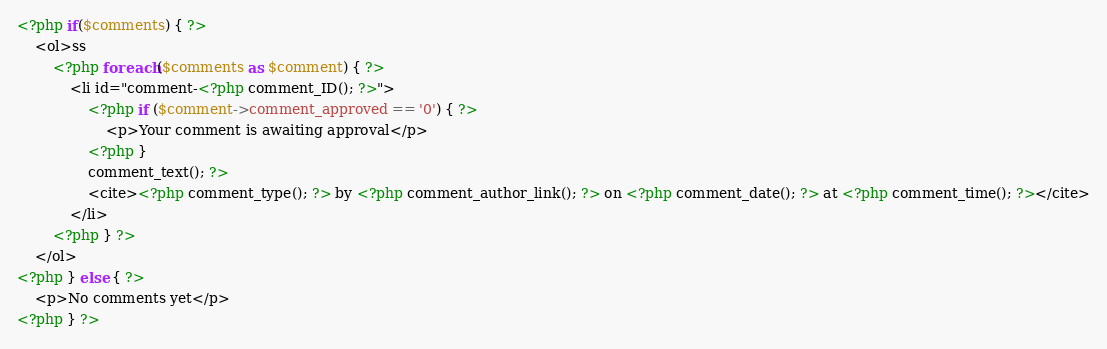<code> <loc_0><loc_0><loc_500><loc_500><_PHP_><?php if($comments) { ?>
    <ol>ss
        <?php foreach($comments as $comment) { ?>
            <li id="comment-<?php comment_ID(); ?>">
                <?php if ($comment->comment_approved == '0') { ?>
                    <p>Your comment is awaiting approval</p>
                <?php }
                comment_text(); ?>
                <cite><?php comment_type(); ?> by <?php comment_author_link(); ?> on <?php comment_date(); ?> at <?php comment_time(); ?></cite>
            </li>
        <?php } ?>
    </ol>
<?php } else { ?>
    <p>No comments yet</p>
<?php } ?></code> 